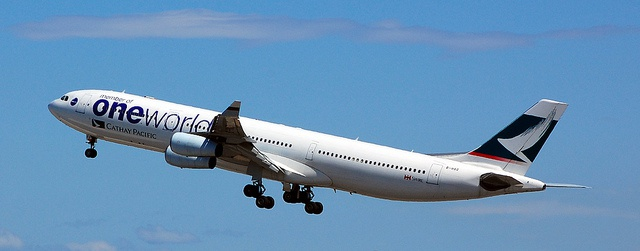Describe the objects in this image and their specific colors. I can see a airplane in gray, white, black, and darkgray tones in this image. 